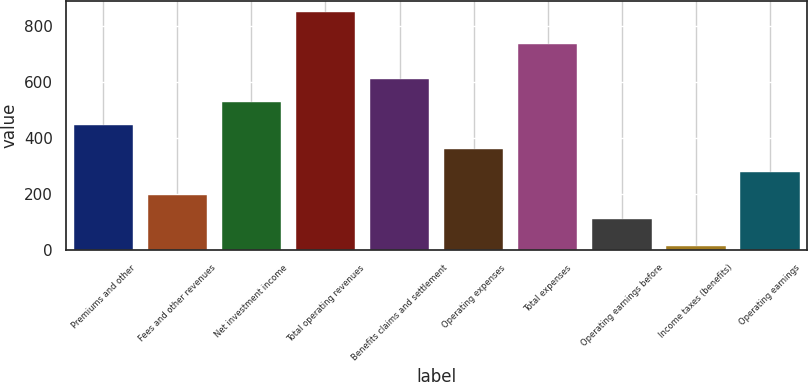<chart> <loc_0><loc_0><loc_500><loc_500><bar_chart><fcel>Premiums and other<fcel>Fees and other revenues<fcel>Net investment income<fcel>Total operating revenues<fcel>Benefits claims and settlement<fcel>Operating expenses<fcel>Total expenses<fcel>Operating earnings before<fcel>Income taxes (benefits)<fcel>Operating earnings<nl><fcel>445.6<fcel>195.25<fcel>529.05<fcel>849<fcel>612.5<fcel>362.15<fcel>737.2<fcel>111.8<fcel>14.5<fcel>278.7<nl></chart> 